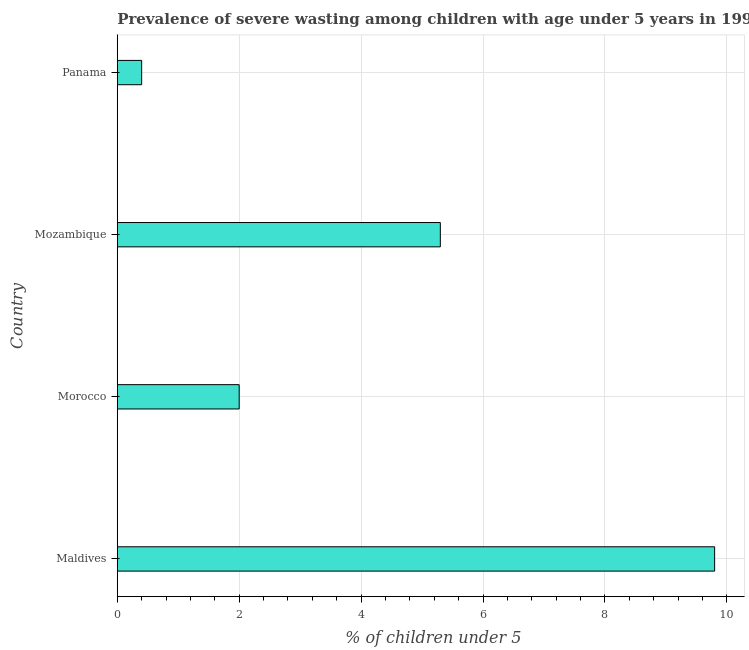What is the title of the graph?
Make the answer very short. Prevalence of severe wasting among children with age under 5 years in 1997. What is the label or title of the X-axis?
Provide a succinct answer.  % of children under 5. What is the prevalence of severe wasting in Maldives?
Your answer should be compact. 9.8. Across all countries, what is the maximum prevalence of severe wasting?
Make the answer very short. 9.8. Across all countries, what is the minimum prevalence of severe wasting?
Your response must be concise. 0.4. In which country was the prevalence of severe wasting maximum?
Keep it short and to the point. Maldives. In which country was the prevalence of severe wasting minimum?
Offer a terse response. Panama. What is the sum of the prevalence of severe wasting?
Give a very brief answer. 17.5. What is the difference between the prevalence of severe wasting in Morocco and Panama?
Ensure brevity in your answer.  1.6. What is the average prevalence of severe wasting per country?
Provide a short and direct response. 4.38. What is the median prevalence of severe wasting?
Offer a very short reply. 3.65. In how many countries, is the prevalence of severe wasting greater than 6.8 %?
Keep it short and to the point. 1. Is the prevalence of severe wasting in Maldives less than that in Panama?
Provide a short and direct response. No. Is the difference between the prevalence of severe wasting in Maldives and Morocco greater than the difference between any two countries?
Offer a very short reply. No. What is the difference between the highest and the second highest prevalence of severe wasting?
Your answer should be compact. 4.5. Is the sum of the prevalence of severe wasting in Maldives and Morocco greater than the maximum prevalence of severe wasting across all countries?
Provide a short and direct response. Yes. Are all the bars in the graph horizontal?
Offer a terse response. Yes. How many countries are there in the graph?
Offer a terse response. 4. Are the values on the major ticks of X-axis written in scientific E-notation?
Your answer should be compact. No. What is the  % of children under 5 of Maldives?
Your answer should be very brief. 9.8. What is the  % of children under 5 of Mozambique?
Offer a terse response. 5.3. What is the  % of children under 5 in Panama?
Make the answer very short. 0.4. What is the difference between the  % of children under 5 in Morocco and Panama?
Your answer should be compact. 1.6. What is the difference between the  % of children under 5 in Mozambique and Panama?
Offer a terse response. 4.9. What is the ratio of the  % of children under 5 in Maldives to that in Morocco?
Your answer should be very brief. 4.9. What is the ratio of the  % of children under 5 in Maldives to that in Mozambique?
Provide a succinct answer. 1.85. What is the ratio of the  % of children under 5 in Maldives to that in Panama?
Ensure brevity in your answer.  24.5. What is the ratio of the  % of children under 5 in Morocco to that in Mozambique?
Provide a succinct answer. 0.38. What is the ratio of the  % of children under 5 in Morocco to that in Panama?
Offer a very short reply. 5. What is the ratio of the  % of children under 5 in Mozambique to that in Panama?
Keep it short and to the point. 13.25. 